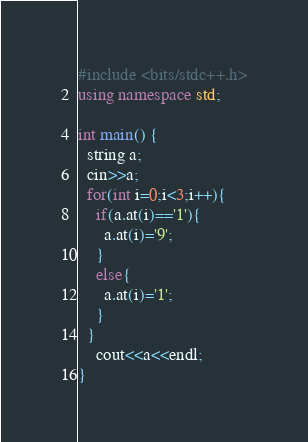Convert code to text. <code><loc_0><loc_0><loc_500><loc_500><_C++_>#include <bits/stdc++.h>
using namespace std;

int main() {
  string a;
  cin>>a;
  for(int i=0;i<3;i++){
    if(a.at(i)=='1'){
      a.at(i)='9';
    }
    else{
      a.at(i)='1';
    }
  }
    cout<<a<<endl;
}
</code> 